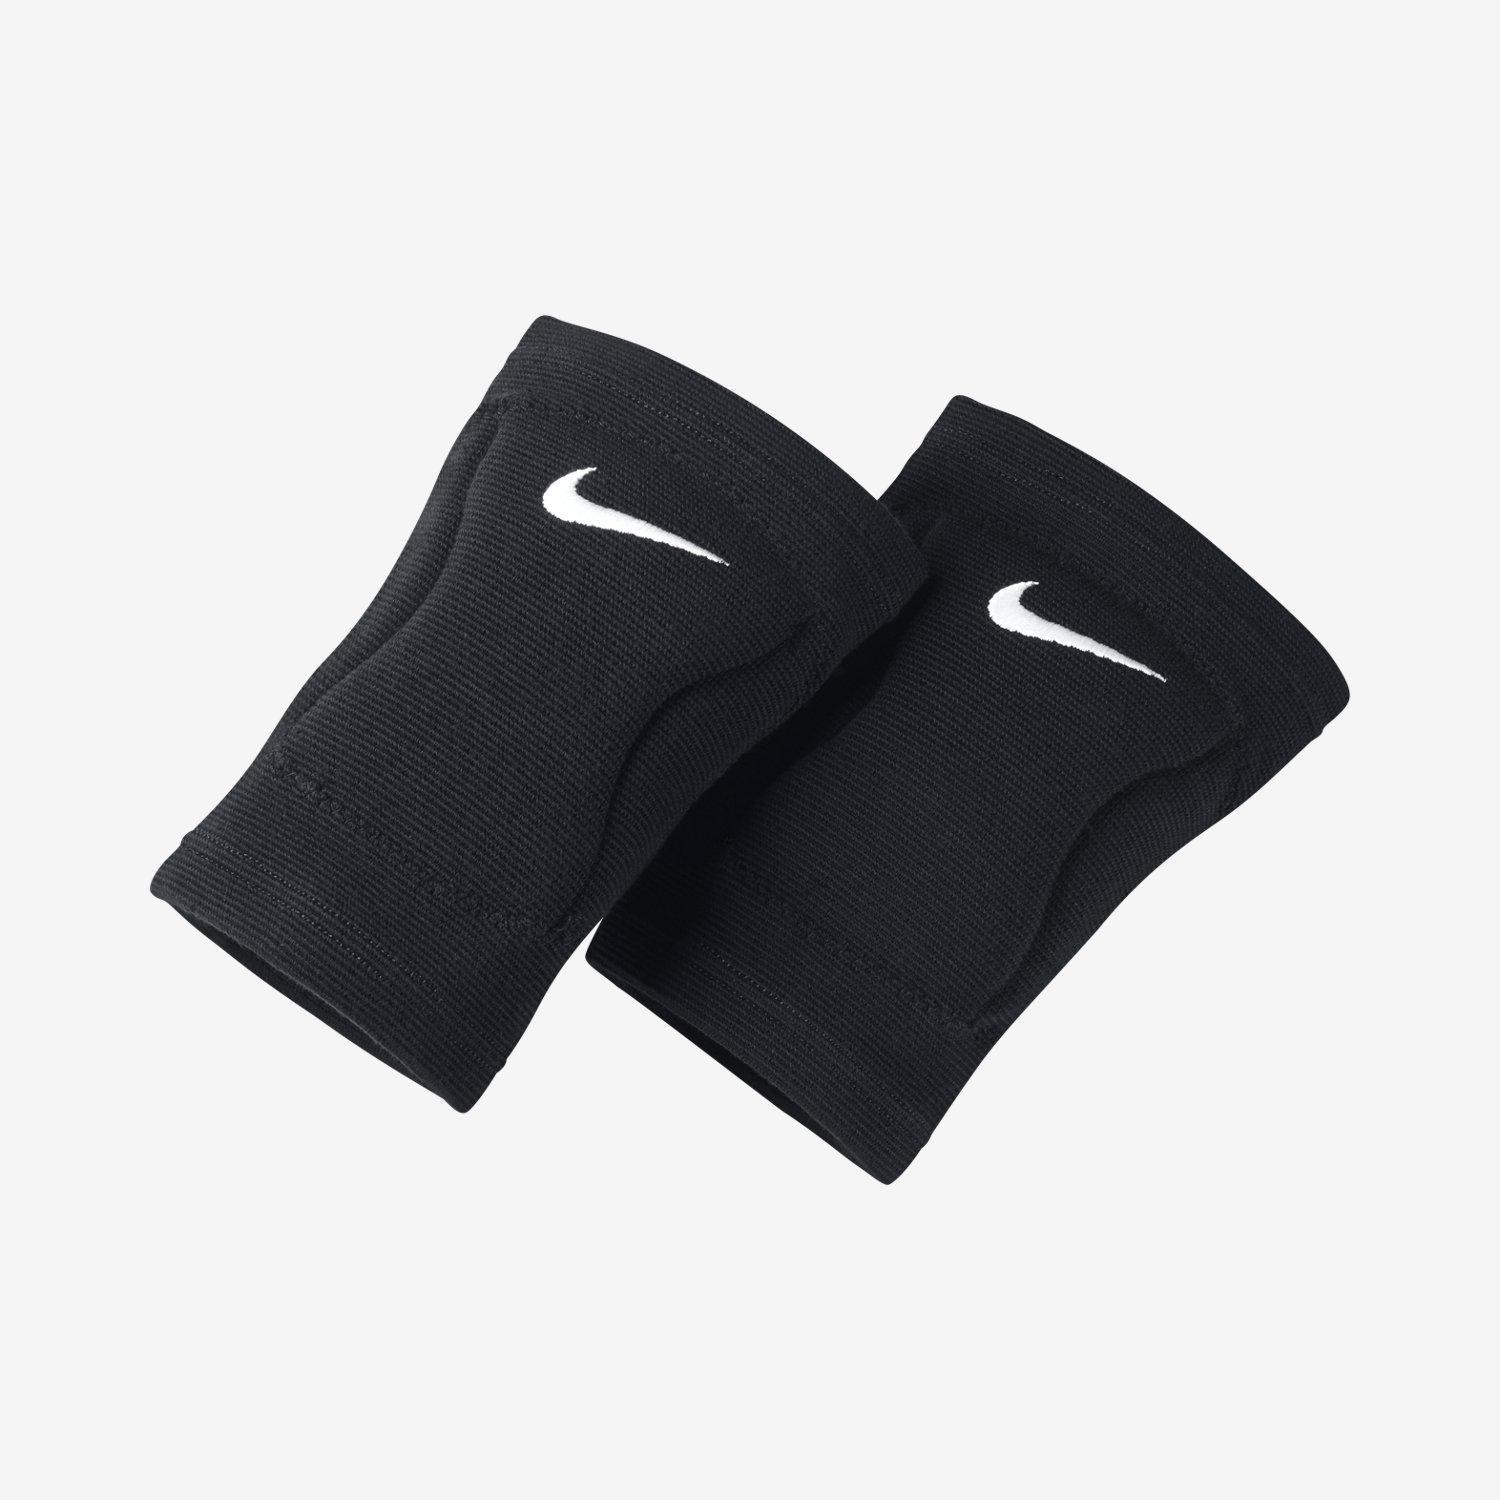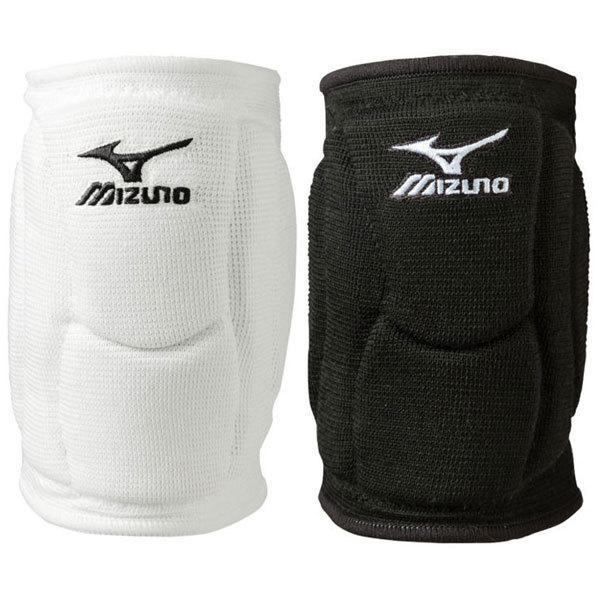The first image is the image on the left, the second image is the image on the right. Evaluate the accuracy of this statement regarding the images: "One of the paired images contains one black brace and one white brace.". Is it true? Answer yes or no. Yes. 